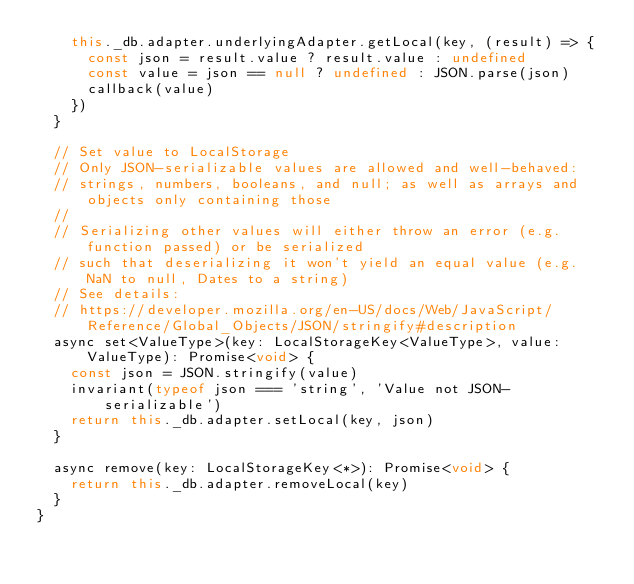<code> <loc_0><loc_0><loc_500><loc_500><_JavaScript_>    this._db.adapter.underlyingAdapter.getLocal(key, (result) => {
      const json = result.value ? result.value : undefined
      const value = json == null ? undefined : JSON.parse(json)
      callback(value)
    })
  }

  // Set value to LocalStorage
  // Only JSON-serializable values are allowed and well-behaved:
  // strings, numbers, booleans, and null; as well as arrays and objects only containing those
  //
  // Serializing other values will either throw an error (e.g. function passed) or be serialized
  // such that deserializing it won't yield an equal value (e.g. NaN to null, Dates to a string)
  // See details:
  // https://developer.mozilla.org/en-US/docs/Web/JavaScript/Reference/Global_Objects/JSON/stringify#description
  async set<ValueType>(key: LocalStorageKey<ValueType>, value: ValueType): Promise<void> {
    const json = JSON.stringify(value)
    invariant(typeof json === 'string', 'Value not JSON-serializable')
    return this._db.adapter.setLocal(key, json)
  }

  async remove(key: LocalStorageKey<*>): Promise<void> {
    return this._db.adapter.removeLocal(key)
  }
}
</code> 